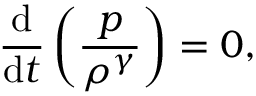<formula> <loc_0><loc_0><loc_500><loc_500>{ \frac { d } { d t } } \left ( { \frac { p } { \rho ^ { \gamma } } } \right ) = 0 ,</formula> 